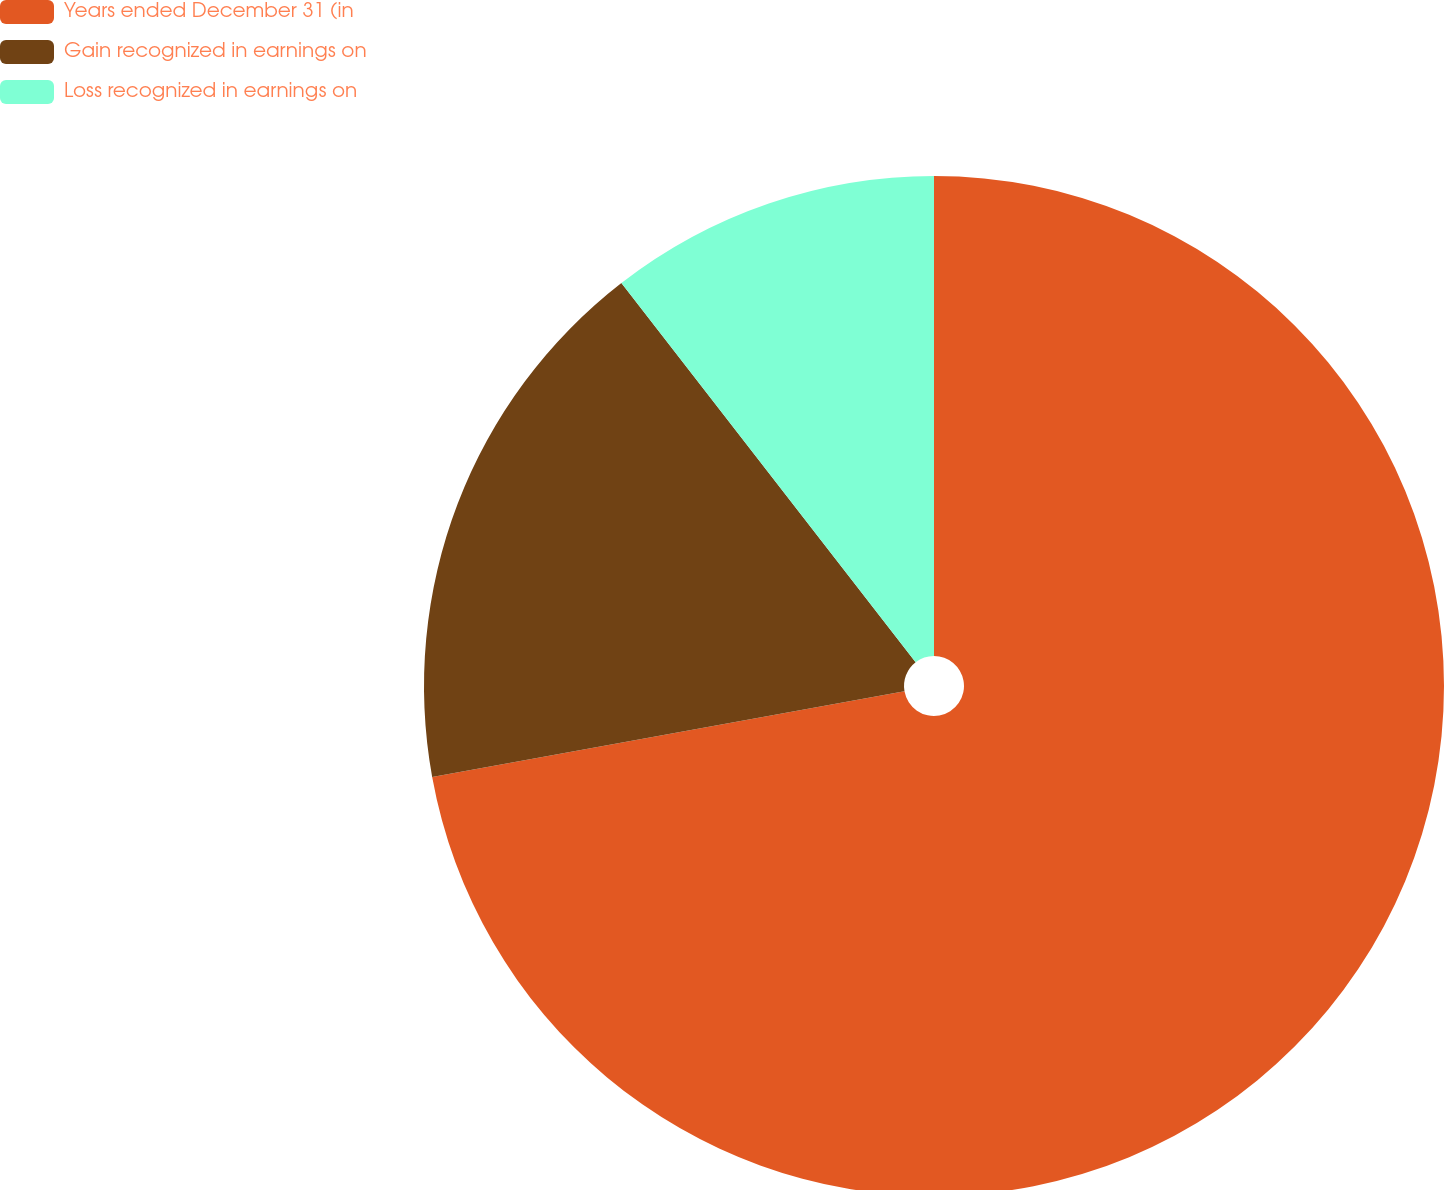<chart> <loc_0><loc_0><loc_500><loc_500><pie_chart><fcel>Years ended December 31 (in<fcel>Gain recognized in earnings on<fcel>Loss recognized in earnings on<nl><fcel>72.14%<fcel>17.35%<fcel>10.5%<nl></chart> 